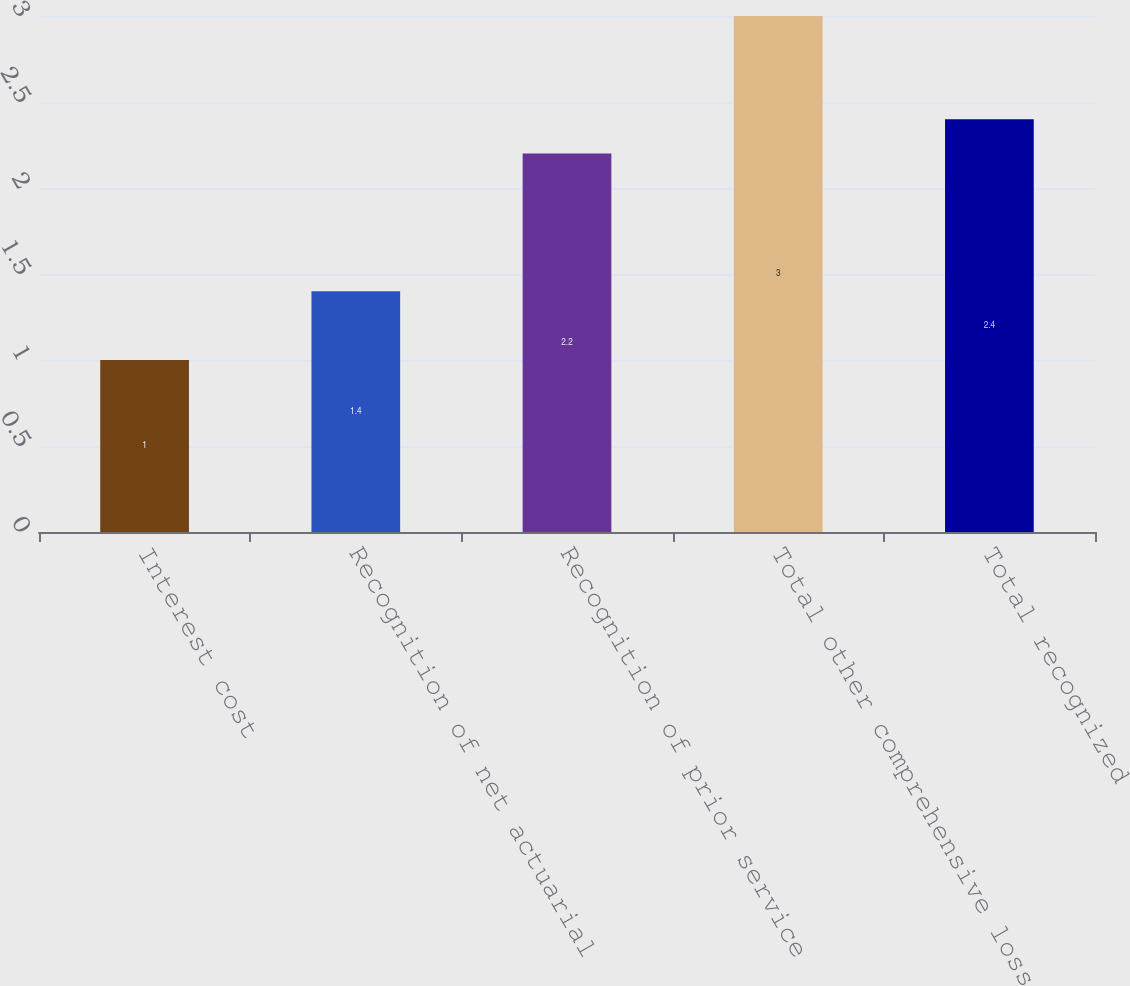Convert chart to OTSL. <chart><loc_0><loc_0><loc_500><loc_500><bar_chart><fcel>Interest cost<fcel>Recognition of net actuarial<fcel>Recognition of prior service<fcel>Total other comprehensive loss<fcel>Total recognized<nl><fcel>1<fcel>1.4<fcel>2.2<fcel>3<fcel>2.4<nl></chart> 